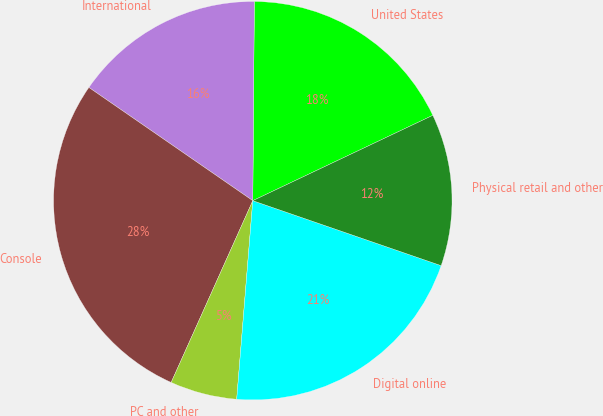Convert chart to OTSL. <chart><loc_0><loc_0><loc_500><loc_500><pie_chart><fcel>United States<fcel>International<fcel>Console<fcel>PC and other<fcel>Digital online<fcel>Physical retail and other<nl><fcel>17.83%<fcel>15.5%<fcel>27.9%<fcel>5.43%<fcel>21.0%<fcel>12.33%<nl></chart> 